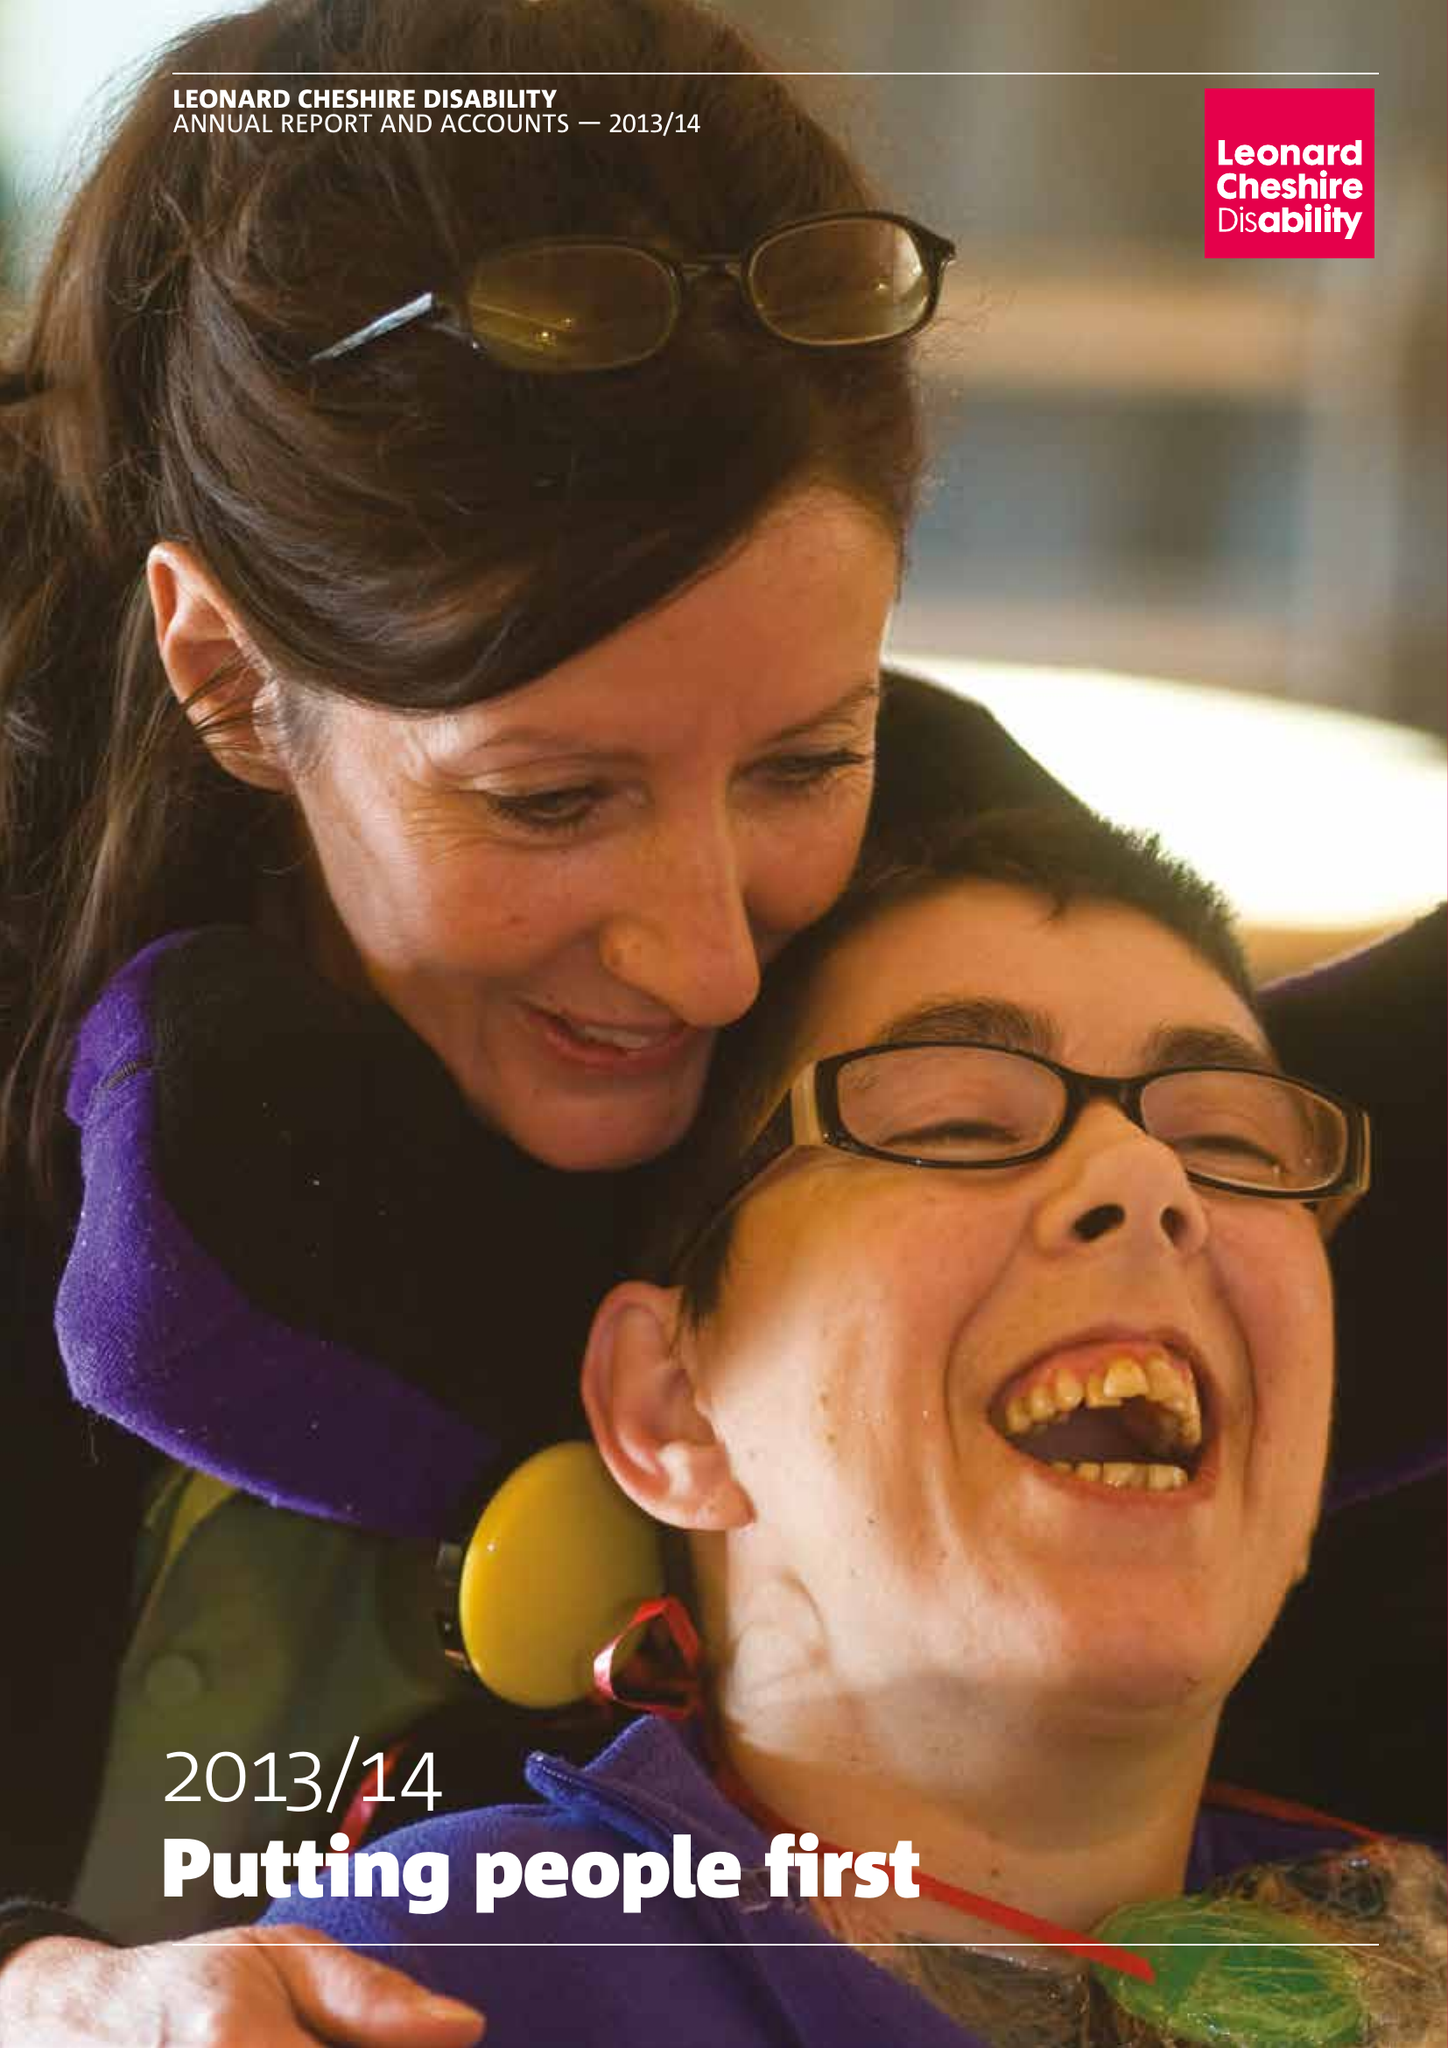What is the value for the income_annually_in_british_pounds?
Answer the question using a single word or phrase. 154559000.00 